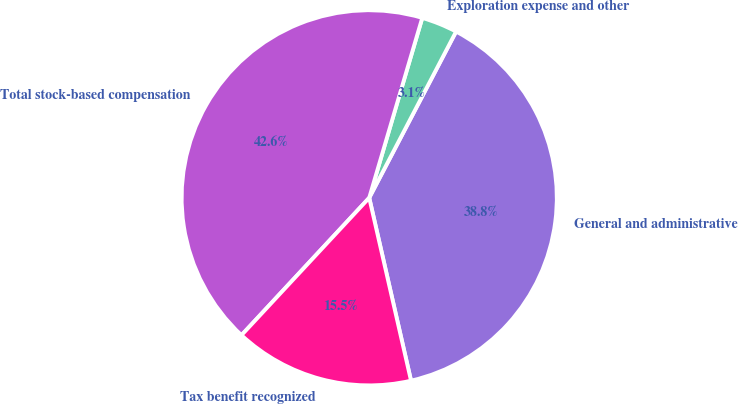<chart> <loc_0><loc_0><loc_500><loc_500><pie_chart><fcel>General and administrative<fcel>Exploration expense and other<fcel>Total stock-based compensation<fcel>Tax benefit recognized<nl><fcel>38.76%<fcel>3.1%<fcel>42.64%<fcel>15.5%<nl></chart> 